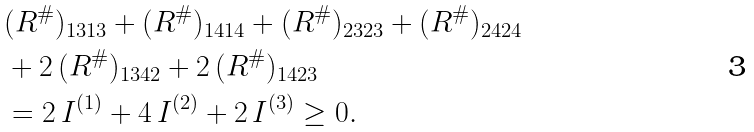Convert formula to latex. <formula><loc_0><loc_0><loc_500><loc_500>& ( R ^ { \# } ) _ { 1 3 1 3 } + ( R ^ { \# } ) _ { 1 4 1 4 } + ( R ^ { \# } ) _ { 2 3 2 3 } + ( R ^ { \# } ) _ { 2 4 2 4 } \\ & + 2 \, ( R ^ { \# } ) _ { 1 3 4 2 } + 2 \, ( R ^ { \# } ) _ { 1 4 2 3 } \\ & = 2 \, I ^ { ( 1 ) } + 4 \, I ^ { ( 2 ) } + 2 \, I ^ { ( 3 ) } \geq 0 .</formula> 